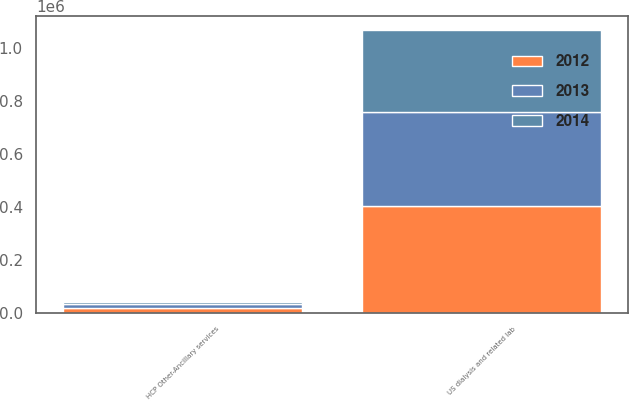<chart> <loc_0><loc_0><loc_500><loc_500><stacked_bar_chart><ecel><fcel>US dialysis and related lab<fcel>HCP Other-Ancillary services<nl><fcel>2012<fcel>402767<fcel>18683<nl><fcel>2013<fcel>355879<fcel>14502<nl><fcel>2014<fcel>310375<fcel>7050<nl></chart> 